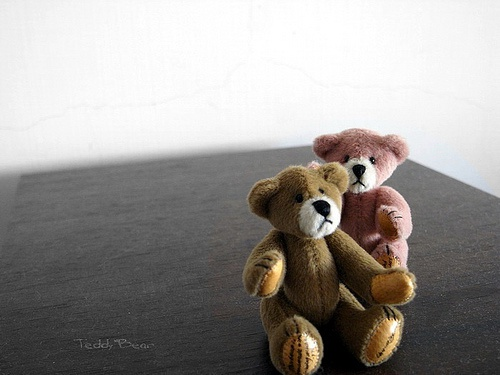Describe the objects in this image and their specific colors. I can see teddy bear in white, black, maroon, and tan tones and teddy bear in white, maroon, lightgray, gray, and black tones in this image. 